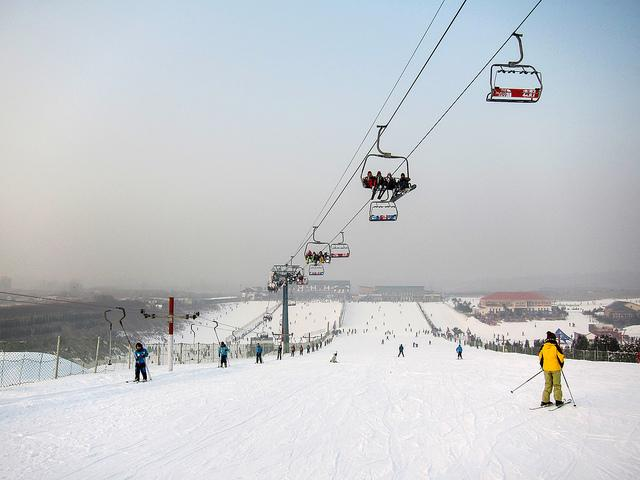What would happen if you cut the top wires?

Choices:
A) nothing
B) can't call
C) laundry falls
D) people injured people injured 